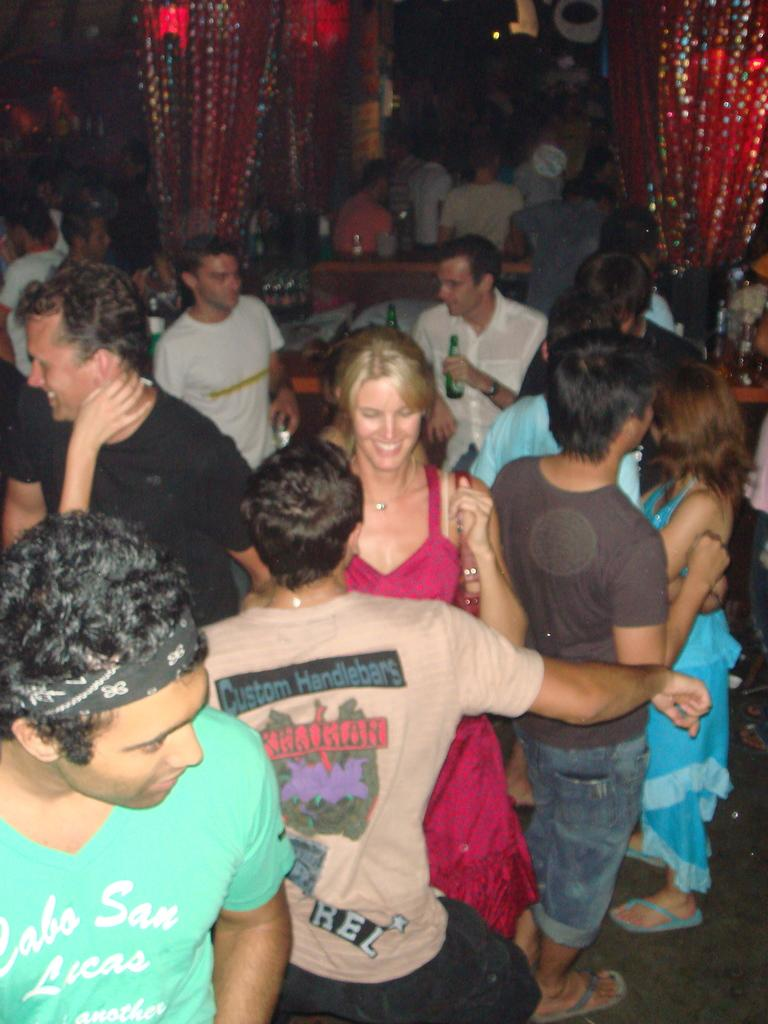How many people are in the image? There is a group of people in the image. What are the people doing in the image? Some people are standing on the floor, and they are smiling. What can be seen in the background of the image? There are red curtains in the background of the image. What type of test can be seen being administered in the image? There is no test present in the image; it features a group of people standing and smiling. What is the color of the front of the room in the image? The provided facts do not mention the front of the room or its color, as the focus is on the people and the red curtains in the background. 